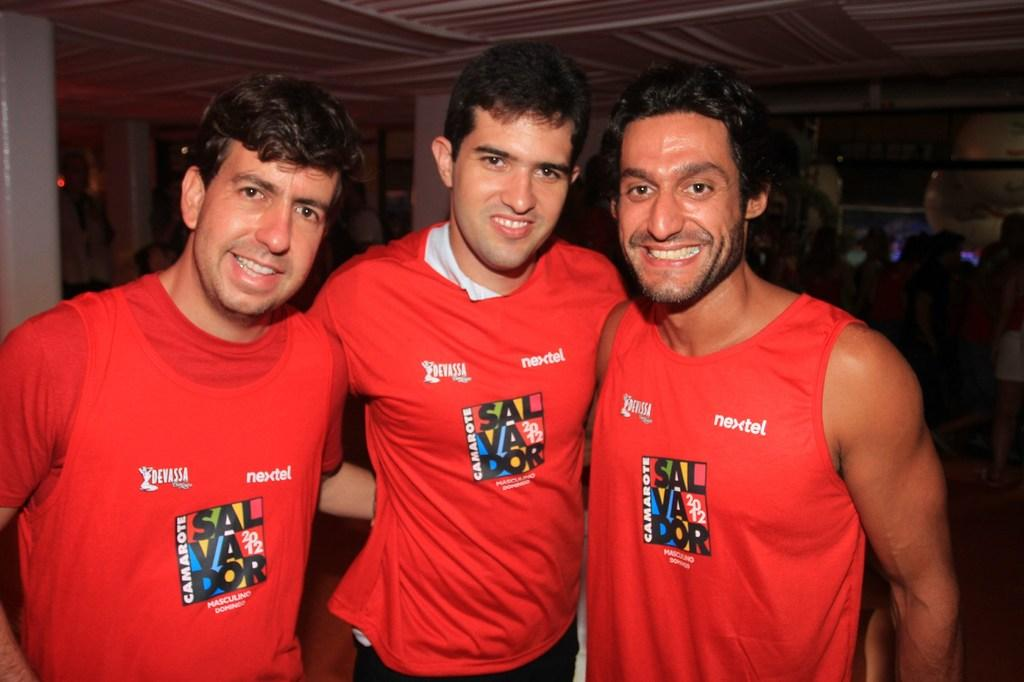How many people are in the image? There are three people in the image. What are the people wearing? The people are wearing red and white color dresses. What can be seen at the top of the image? There is a ceiling visible at the top of the image. What is the color of the background in the image? The background of the image is black. How many babies are being supported by the door in the image? There are no babies or doors present in the image. 